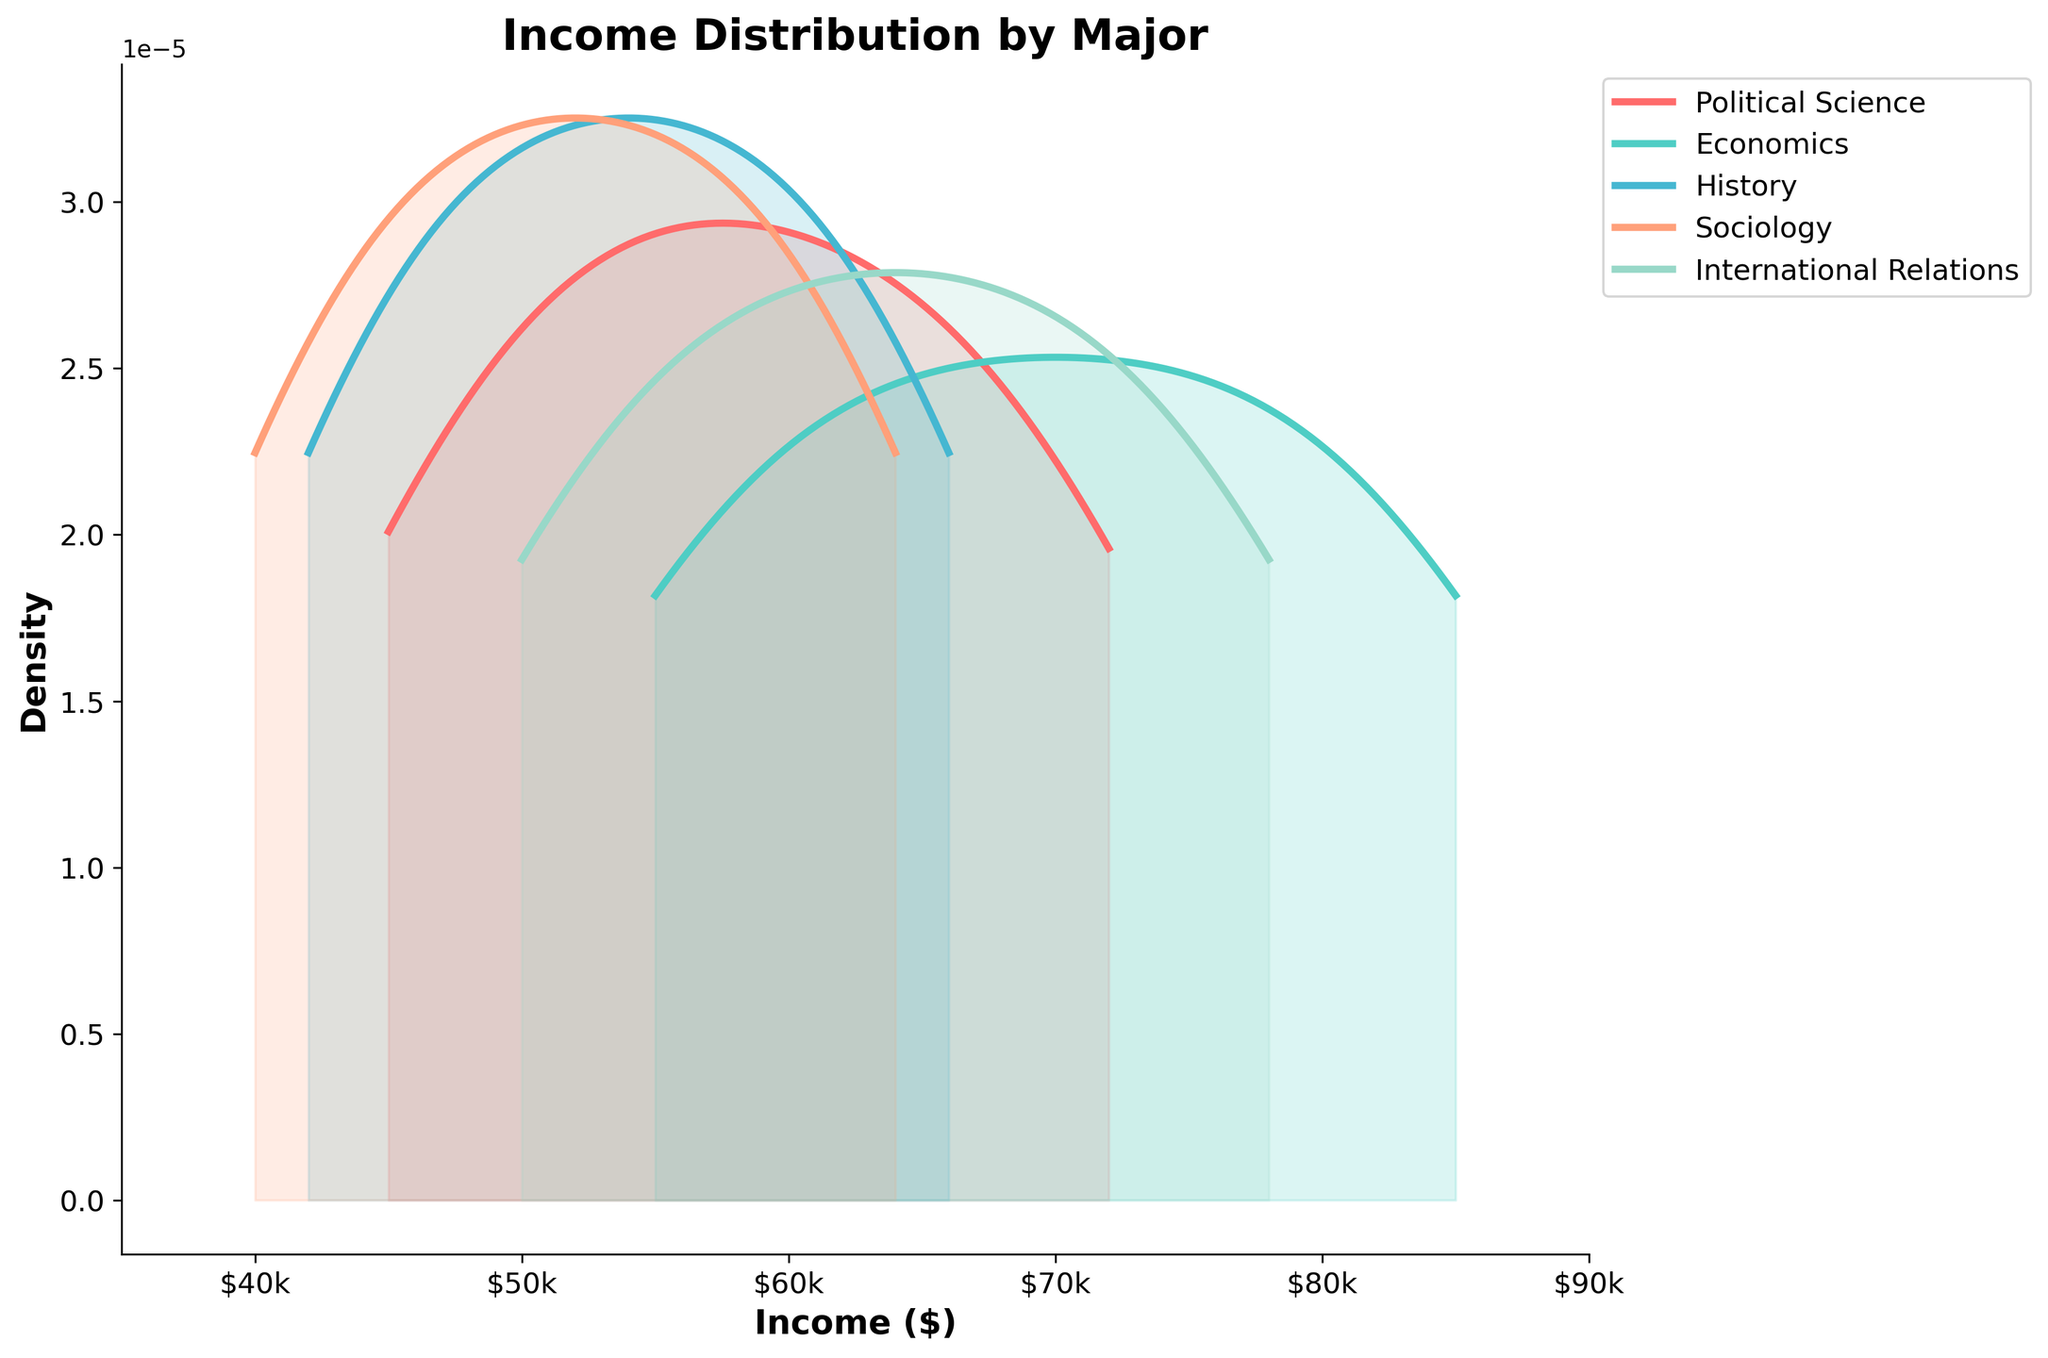What is the title of the plot? The title is usually located at the top of the plot and gives a brief description of what the plot represents. In this case, it says "Income Distribution by Major."
Answer: Income Distribution by Major What is the label of the x-axis? The x-axis label is usually located at the bottom of the plot and it describes the data along the horizontal axis. Here, it is labeled "Income ($)."
Answer: Income ($) Which major appears to have the highest density peak in income distribution? To determine which major has the highest density peak, we look for the tallest peak among the density curves. Economics seems to have the tallest peak.
Answer: Economics What is the approximate income range where Political Science has the highest density? The highest density of Political Science can be identified by the peak of its curve. This peak is approximately around $65,000.
Answer: $65,000 Which major has the widest spread in income distribution? The width of the distribution can be observed by looking at how wide the curves are along the income axis. International Relations has the widest spread ranging from around $50,000 to $78,000.
Answer: International Relations How does the density of History graduates compare to Sociology graduates at $55,000 income? To compare the densities, check the height of the curves for History and Sociology at the $55,000 mark. The History density curve is higher than that of Sociology at this income.
Answer: History higher Which majors have a density curve that intersects with International Relations? By observing the plot, the density curves of Political Science and Economics intersect with International Relations, as they share common income ranges and cross each other's paths.
Answer: Political Science, Economics What is the peak density value for International Relations? To find the peak density value for International Relations, locate the highest point on its density curve. This peak appears to be around $64,000.
Answer: $64,000 Between History and Sociology, which major shows a higher income distribution density around $50,000? By comparing the curves at the $50,000 mark, History shows a higher density than Sociology.
Answer: History 